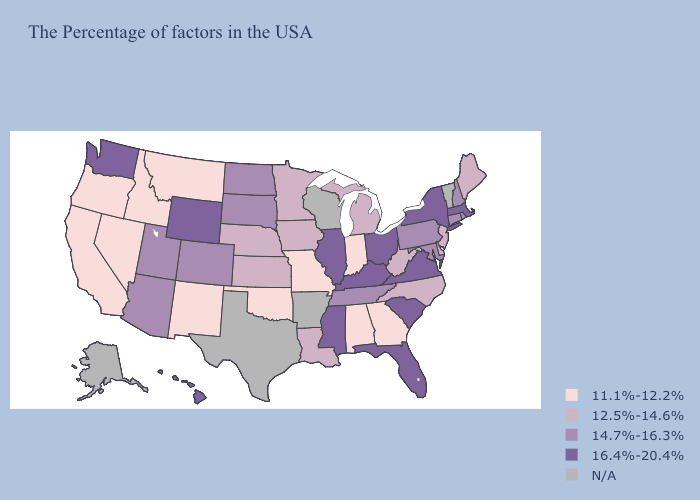Does Missouri have the highest value in the USA?
Quick response, please. No. Does New Jersey have the lowest value in the Northeast?
Keep it brief. Yes. Name the states that have a value in the range 11.1%-12.2%?
Quick response, please. Georgia, Indiana, Alabama, Missouri, Oklahoma, New Mexico, Montana, Idaho, Nevada, California, Oregon. What is the value of Missouri?
Be succinct. 11.1%-12.2%. Name the states that have a value in the range 16.4%-20.4%?
Be succinct. Massachusetts, New York, Virginia, South Carolina, Ohio, Florida, Kentucky, Illinois, Mississippi, Wyoming, Washington, Hawaii. Among the states that border Rhode Island , does Massachusetts have the lowest value?
Keep it brief. No. Which states have the lowest value in the MidWest?
Concise answer only. Indiana, Missouri. Does the map have missing data?
Be succinct. Yes. What is the lowest value in the USA?
Keep it brief. 11.1%-12.2%. What is the highest value in states that border Kansas?
Be succinct. 14.7%-16.3%. Which states have the highest value in the USA?
Be succinct. Massachusetts, New York, Virginia, South Carolina, Ohio, Florida, Kentucky, Illinois, Mississippi, Wyoming, Washington, Hawaii. Which states have the lowest value in the West?
Write a very short answer. New Mexico, Montana, Idaho, Nevada, California, Oregon. Among the states that border Indiana , does Kentucky have the lowest value?
Quick response, please. No. Is the legend a continuous bar?
Be succinct. No. 